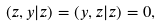Convert formula to latex. <formula><loc_0><loc_0><loc_500><loc_500>\left ( z , y | z \right ) = \left ( y , z | z \right ) = 0 ,</formula> 